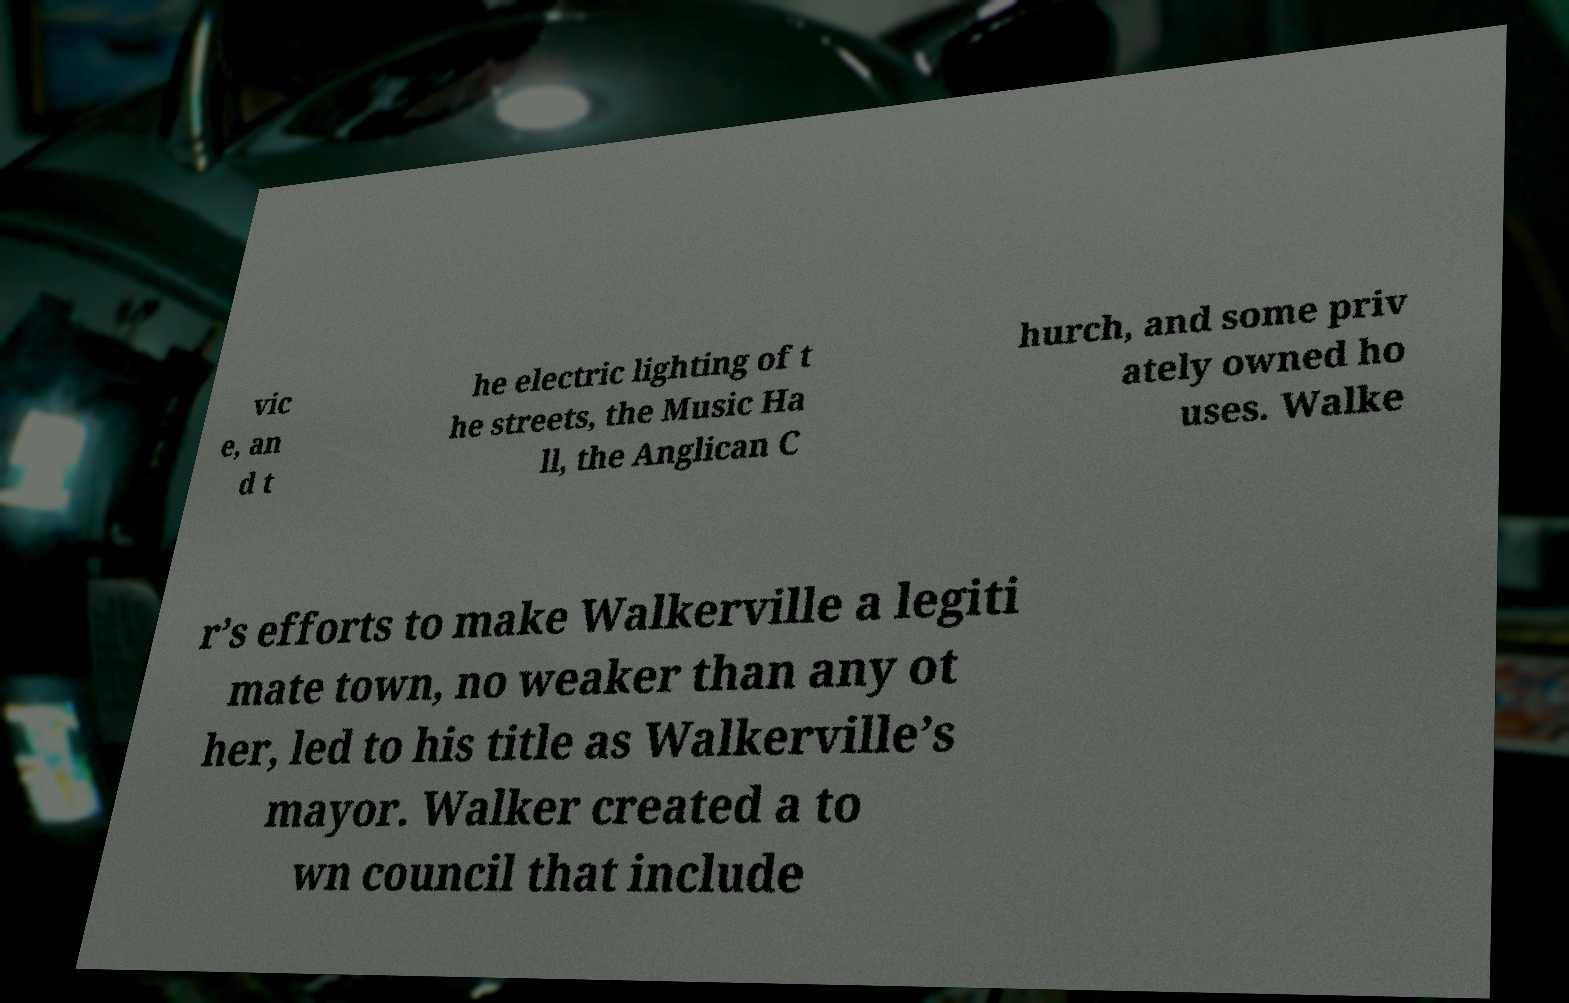For documentation purposes, I need the text within this image transcribed. Could you provide that? vic e, an d t he electric lighting of t he streets, the Music Ha ll, the Anglican C hurch, and some priv ately owned ho uses. Walke r’s efforts to make Walkerville a legiti mate town, no weaker than any ot her, led to his title as Walkerville’s mayor. Walker created a to wn council that include 